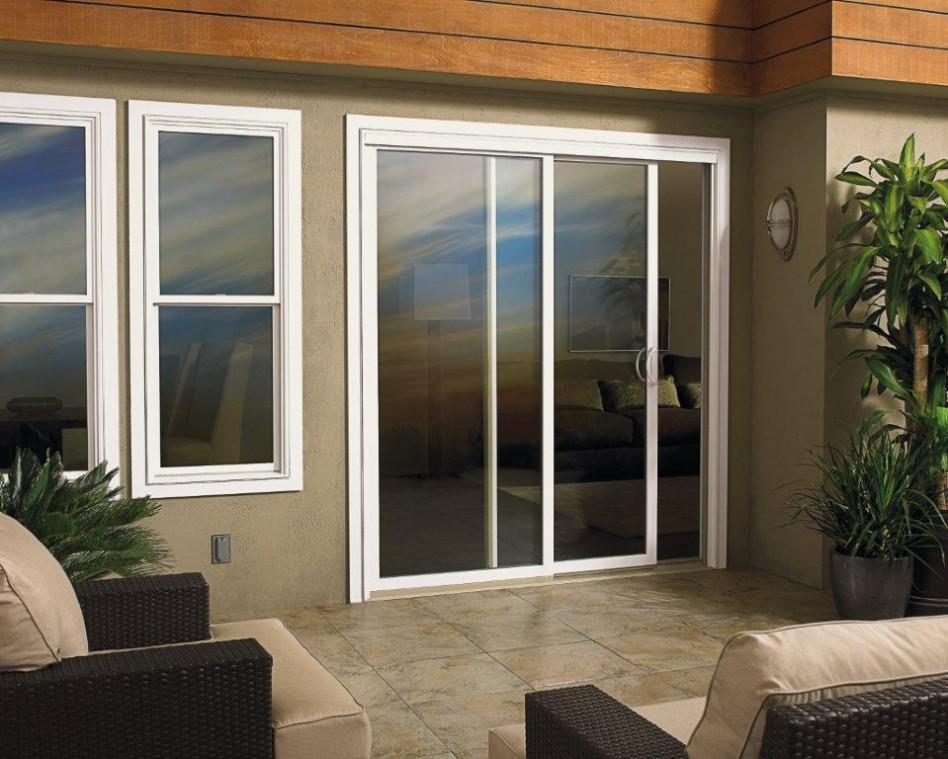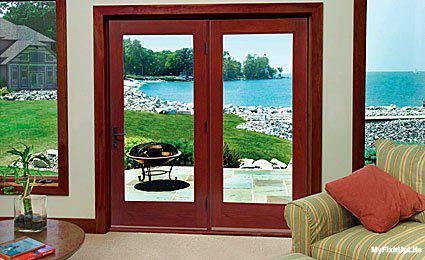The first image is the image on the left, the second image is the image on the right. For the images shown, is this caption "Three equal size segments make up each glass door and window panel installation with discreet door hardware visible on one panel." true? Answer yes or no. No. 